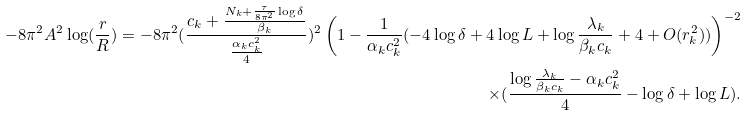Convert formula to latex. <formula><loc_0><loc_0><loc_500><loc_500>- 8 \pi ^ { 2 } A ^ { 2 } \log ( \frac { r } { R } ) = - 8 \pi ^ { 2 } ( \frac { c _ { k } + \frac { N _ { k } + \frac { \tau } { 8 \pi ^ { 2 } } \log \delta } { \beta _ { k } } } { \frac { \alpha _ { k } c _ { k } ^ { 2 } } { 4 } } ) ^ { 2 } \left ( 1 - \frac { 1 } { \alpha _ { k } c _ { k } ^ { 2 } } ( - 4 \log \delta + 4 \log L + \log \frac { \lambda _ { k } } { \beta _ { k } c _ { k } } + 4 + O ( r _ { k } ^ { 2 } ) ) \right ) ^ { - 2 } \\ \times ( \frac { \log \frac { \lambda _ { k } } { \beta _ { k } c _ { k } } - \alpha _ { k } c _ { k } ^ { 2 } } { 4 } - \log \delta + \log L ) .</formula> 